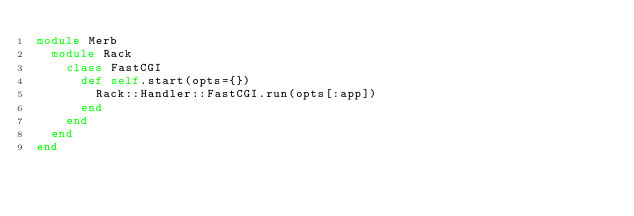<code> <loc_0><loc_0><loc_500><loc_500><_Ruby_>module Merb
  module Rack
    class FastCGI
      def self.start(opts={})
        Rack::Handler::FastCGI.run(opts[:app])
      end
    end
  end
end
</code> 